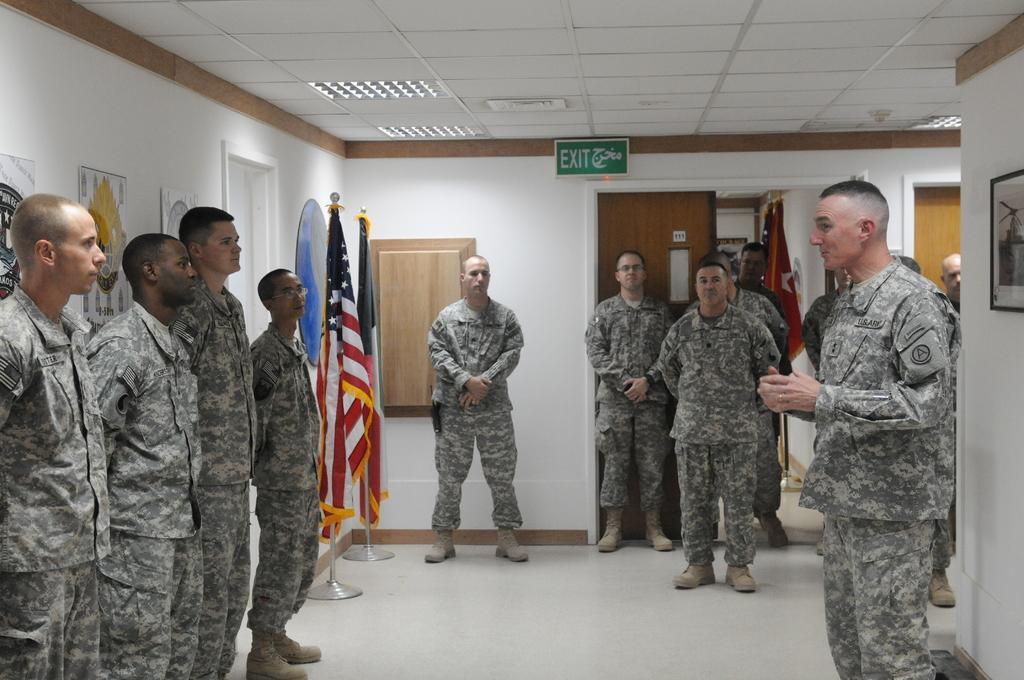Could you give a brief overview of what you see in this image? In this image there are people standing near the walls, on that wall there are photo frames and there are flags, at the top there is a ceiling and there are lights. 